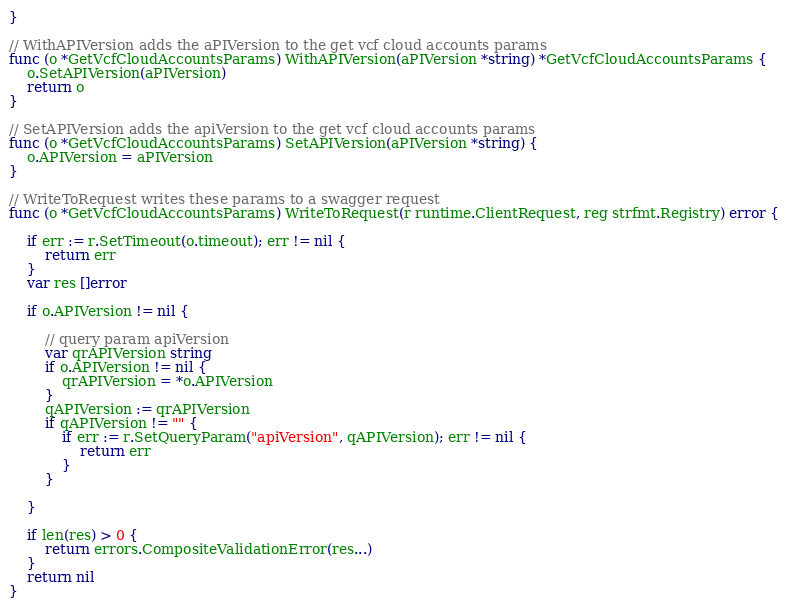<code> <loc_0><loc_0><loc_500><loc_500><_Go_>}

// WithAPIVersion adds the aPIVersion to the get vcf cloud accounts params
func (o *GetVcfCloudAccountsParams) WithAPIVersion(aPIVersion *string) *GetVcfCloudAccountsParams {
	o.SetAPIVersion(aPIVersion)
	return o
}

// SetAPIVersion adds the apiVersion to the get vcf cloud accounts params
func (o *GetVcfCloudAccountsParams) SetAPIVersion(aPIVersion *string) {
	o.APIVersion = aPIVersion
}

// WriteToRequest writes these params to a swagger request
func (o *GetVcfCloudAccountsParams) WriteToRequest(r runtime.ClientRequest, reg strfmt.Registry) error {

	if err := r.SetTimeout(o.timeout); err != nil {
		return err
	}
	var res []error

	if o.APIVersion != nil {

		// query param apiVersion
		var qrAPIVersion string
		if o.APIVersion != nil {
			qrAPIVersion = *o.APIVersion
		}
		qAPIVersion := qrAPIVersion
		if qAPIVersion != "" {
			if err := r.SetQueryParam("apiVersion", qAPIVersion); err != nil {
				return err
			}
		}

	}

	if len(res) > 0 {
		return errors.CompositeValidationError(res...)
	}
	return nil
}
</code> 